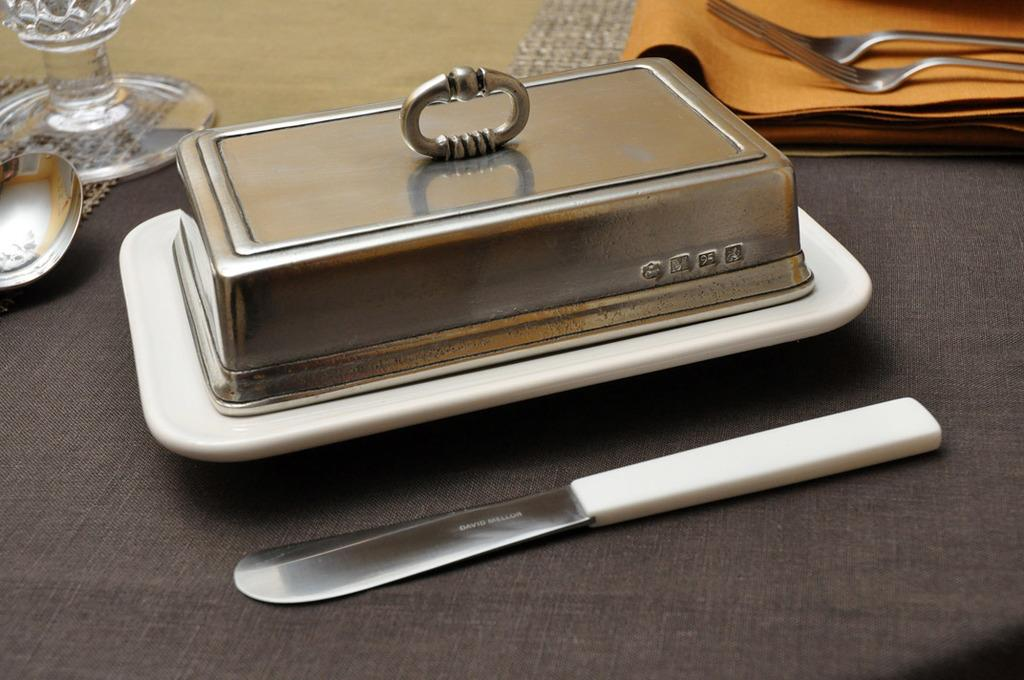What is on the plate in the image? There is a lid on a plate in the image. What utensil is placed beside the plate? There is a knife beside the plate in the image. Where are the forks located in the image? The forks are on a cloth in the top right of the image. What other items can be seen in the top left of the image? There is a glass and a spoon in the top left of the image. How many lizards are crawling on the glass in the image? There are no lizards present in the image; it only features a glass, a spoon, a plate with a lid, a knife, forks, and a cloth. 